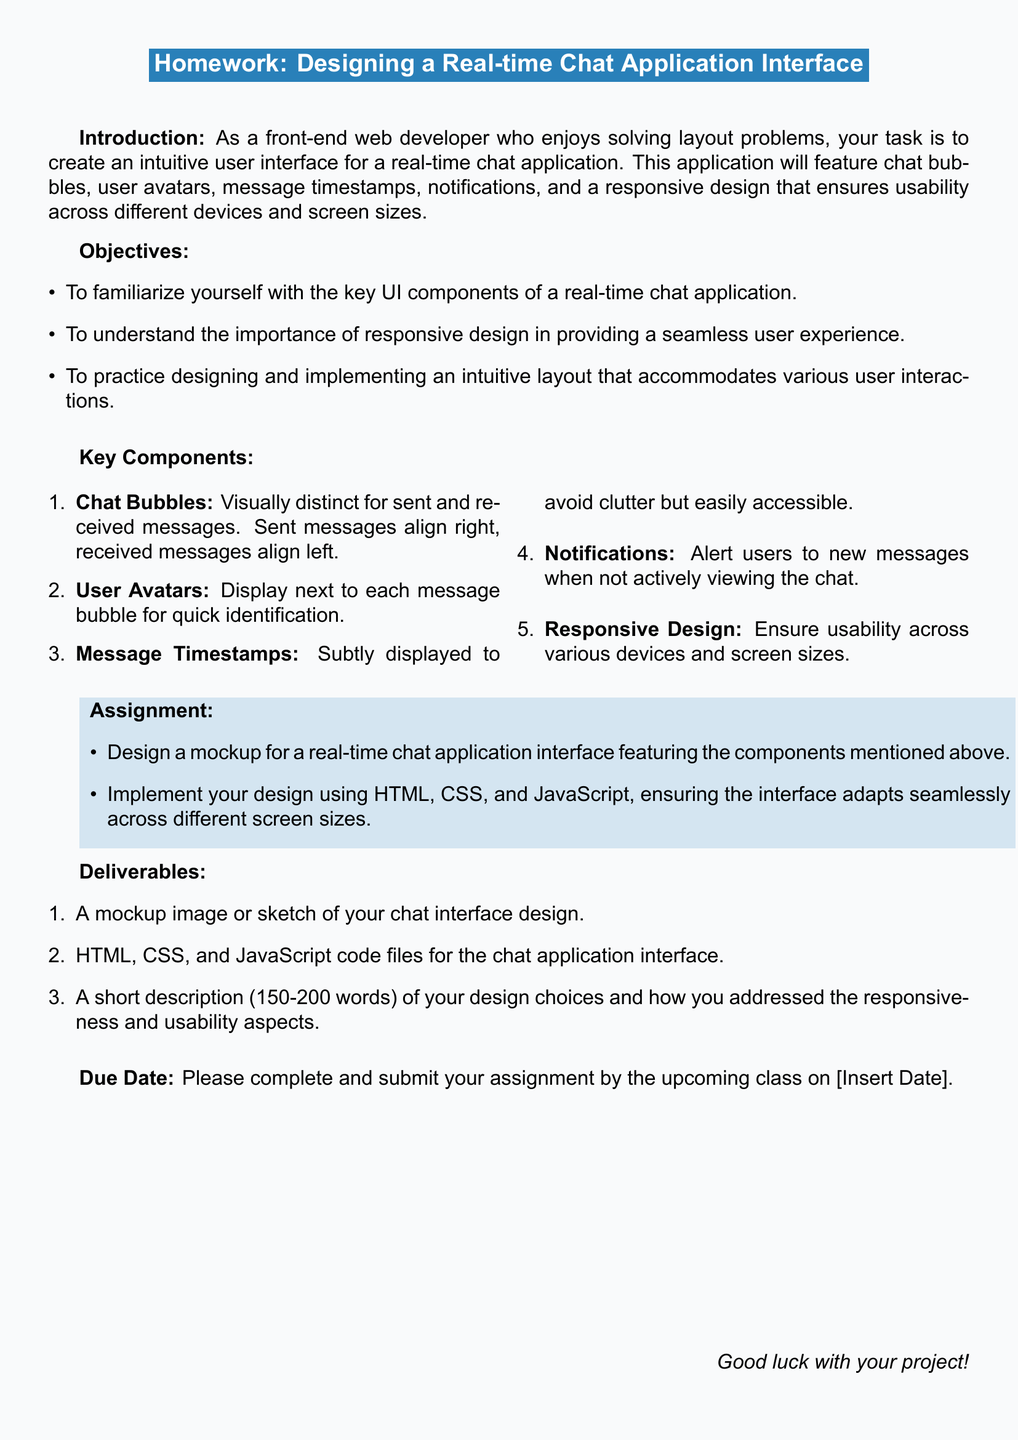What is the title of the homework? The title of the homework is displayed prominently in the document.
Answer: Designing a Real-time Chat Application Interface What is one of the objectives of the homework? The objectives include familiarizing with UI components, understanding responsive design, and practicing layout design.
Answer: To familiarize yourself with the key UI components of a real-time chat application How many key components are listed in the document? The document includes a list of key components that are essential for the chat application interface.
Answer: Five What must be submitted as part of the deliverables? The deliverables section lists specific items to be submitted for the homework assignment.
Answer: A mockup image or sketch of your chat interface design What color is used for the header background? The color used for the header background is specifically defined in the document.
Answer: webblue What alignment should sent messages have? The document specifies the alignment for sent messages in the chat application interface.
Answer: Right What is the maximum word count for the description of design choices? The document states a specific word count requirement for the short description of the design choices.
Answer: 200 words What is the due date format mentioned in the document? The due date section requires a specific information format to be filled in.
Answer: Insert Date What type of design is emphasized in the homework? The document highlights the importance of a specific type of design for the chat application.
Answer: Responsive design 